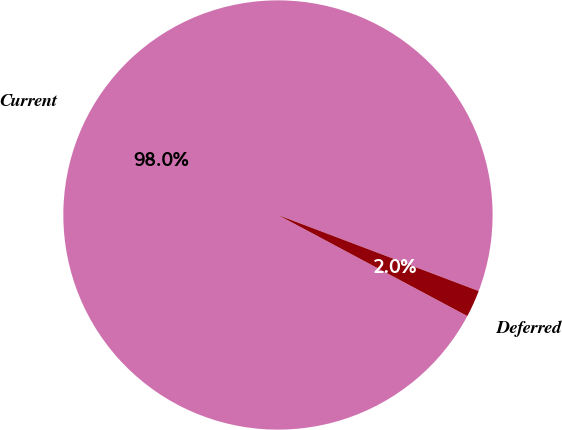<chart> <loc_0><loc_0><loc_500><loc_500><pie_chart><fcel>Current<fcel>Deferred<nl><fcel>97.96%<fcel>2.04%<nl></chart> 